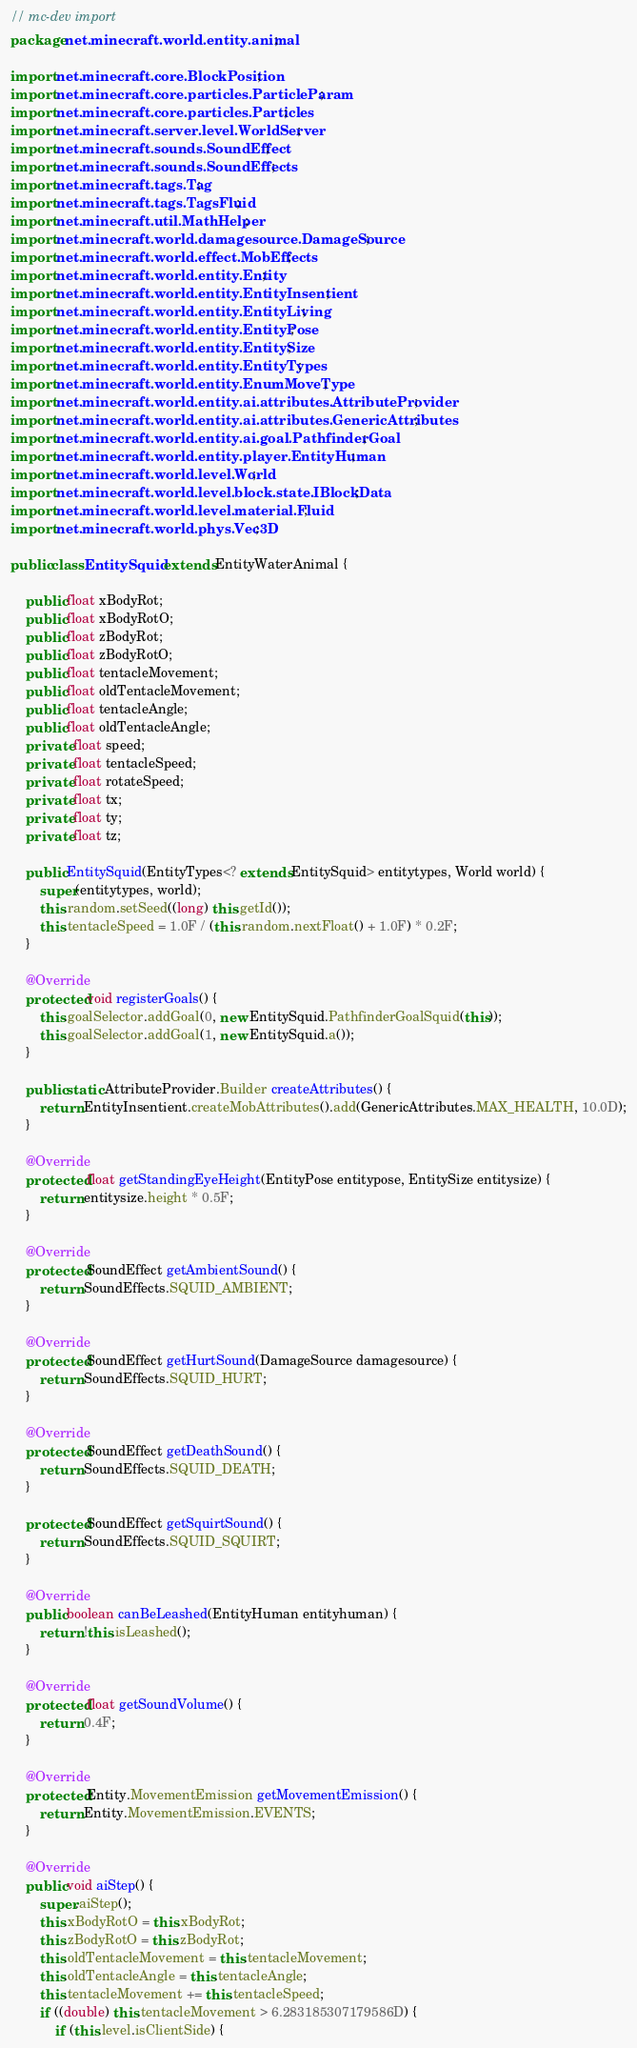Convert code to text. <code><loc_0><loc_0><loc_500><loc_500><_Java_>// mc-dev import
package net.minecraft.world.entity.animal;

import net.minecraft.core.BlockPosition;
import net.minecraft.core.particles.ParticleParam;
import net.minecraft.core.particles.Particles;
import net.minecraft.server.level.WorldServer;
import net.minecraft.sounds.SoundEffect;
import net.minecraft.sounds.SoundEffects;
import net.minecraft.tags.Tag;
import net.minecraft.tags.TagsFluid;
import net.minecraft.util.MathHelper;
import net.minecraft.world.damagesource.DamageSource;
import net.minecraft.world.effect.MobEffects;
import net.minecraft.world.entity.Entity;
import net.minecraft.world.entity.EntityInsentient;
import net.minecraft.world.entity.EntityLiving;
import net.minecraft.world.entity.EntityPose;
import net.minecraft.world.entity.EntitySize;
import net.minecraft.world.entity.EntityTypes;
import net.minecraft.world.entity.EnumMoveType;
import net.minecraft.world.entity.ai.attributes.AttributeProvider;
import net.minecraft.world.entity.ai.attributes.GenericAttributes;
import net.minecraft.world.entity.ai.goal.PathfinderGoal;
import net.minecraft.world.entity.player.EntityHuman;
import net.minecraft.world.level.World;
import net.minecraft.world.level.block.state.IBlockData;
import net.minecraft.world.level.material.Fluid;
import net.minecraft.world.phys.Vec3D;

public class EntitySquid extends EntityWaterAnimal {

    public float xBodyRot;
    public float xBodyRotO;
    public float zBodyRot;
    public float zBodyRotO;
    public float tentacleMovement;
    public float oldTentacleMovement;
    public float tentacleAngle;
    public float oldTentacleAngle;
    private float speed;
    private float tentacleSpeed;
    private float rotateSpeed;
    private float tx;
    private float ty;
    private float tz;

    public EntitySquid(EntityTypes<? extends EntitySquid> entitytypes, World world) {
        super(entitytypes, world);
        this.random.setSeed((long) this.getId());
        this.tentacleSpeed = 1.0F / (this.random.nextFloat() + 1.0F) * 0.2F;
    }

    @Override
    protected void registerGoals() {
        this.goalSelector.addGoal(0, new EntitySquid.PathfinderGoalSquid(this));
        this.goalSelector.addGoal(1, new EntitySquid.a());
    }

    public static AttributeProvider.Builder createAttributes() {
        return EntityInsentient.createMobAttributes().add(GenericAttributes.MAX_HEALTH, 10.0D);
    }

    @Override
    protected float getStandingEyeHeight(EntityPose entitypose, EntitySize entitysize) {
        return entitysize.height * 0.5F;
    }

    @Override
    protected SoundEffect getAmbientSound() {
        return SoundEffects.SQUID_AMBIENT;
    }

    @Override
    protected SoundEffect getHurtSound(DamageSource damagesource) {
        return SoundEffects.SQUID_HURT;
    }

    @Override
    protected SoundEffect getDeathSound() {
        return SoundEffects.SQUID_DEATH;
    }

    protected SoundEffect getSquirtSound() {
        return SoundEffects.SQUID_SQUIRT;
    }

    @Override
    public boolean canBeLeashed(EntityHuman entityhuman) {
        return !this.isLeashed();
    }

    @Override
    protected float getSoundVolume() {
        return 0.4F;
    }

    @Override
    protected Entity.MovementEmission getMovementEmission() {
        return Entity.MovementEmission.EVENTS;
    }

    @Override
    public void aiStep() {
        super.aiStep();
        this.xBodyRotO = this.xBodyRot;
        this.zBodyRotO = this.zBodyRot;
        this.oldTentacleMovement = this.tentacleMovement;
        this.oldTentacleAngle = this.tentacleAngle;
        this.tentacleMovement += this.tentacleSpeed;
        if ((double) this.tentacleMovement > 6.283185307179586D) {
            if (this.level.isClientSide) {</code> 